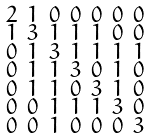<formula> <loc_0><loc_0><loc_500><loc_500>\begin{smallmatrix} 2 & 1 & 0 & 0 & 0 & 0 & 0 \\ 1 & 3 & 1 & 1 & 1 & 0 & 0 \\ 0 & 1 & 3 & 1 & 1 & 1 & 1 \\ 0 & 1 & 1 & 3 & 0 & 1 & 0 \\ 0 & 1 & 1 & 0 & 3 & 1 & 0 \\ 0 & 0 & 1 & 1 & 1 & 3 & 0 \\ 0 & 0 & 1 & 0 & 0 & 0 & 3 \end{smallmatrix}</formula> 